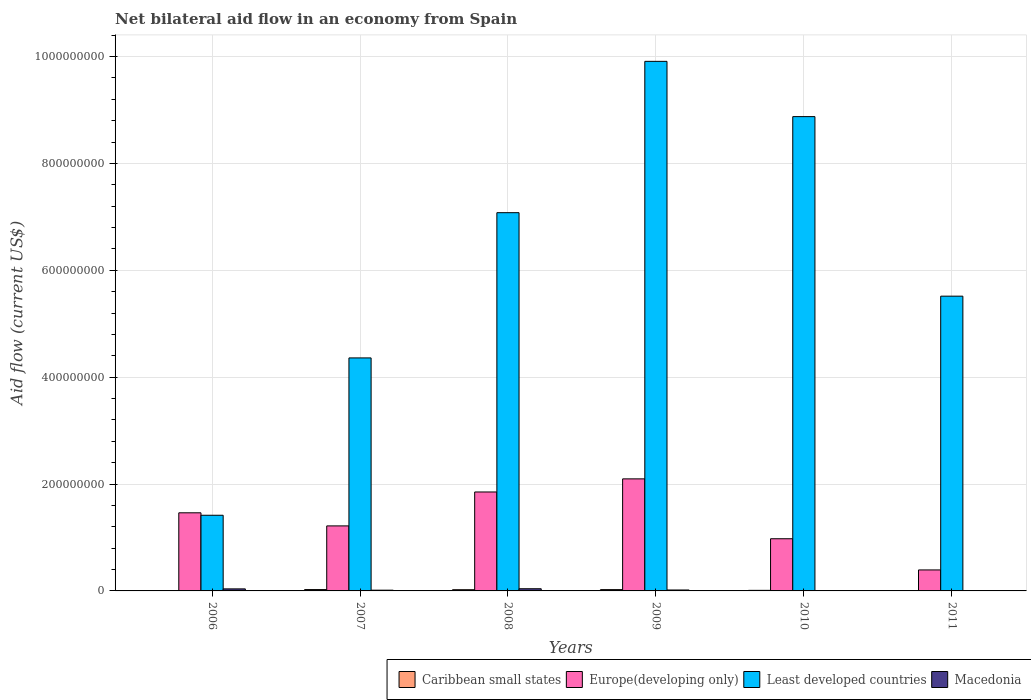How many different coloured bars are there?
Your answer should be compact. 4. Are the number of bars per tick equal to the number of legend labels?
Offer a terse response. Yes. Are the number of bars on each tick of the X-axis equal?
Keep it short and to the point. Yes. How many bars are there on the 1st tick from the left?
Offer a very short reply. 4. How many bars are there on the 6th tick from the right?
Your response must be concise. 4. What is the label of the 5th group of bars from the left?
Your response must be concise. 2010. What is the net bilateral aid flow in Macedonia in 2007?
Your answer should be compact. 1.38e+06. Across all years, what is the maximum net bilateral aid flow in Macedonia?
Keep it short and to the point. 4.07e+06. Across all years, what is the minimum net bilateral aid flow in Europe(developing only)?
Offer a terse response. 3.93e+07. What is the total net bilateral aid flow in Macedonia in the graph?
Ensure brevity in your answer.  1.14e+07. What is the difference between the net bilateral aid flow in Caribbean small states in 2006 and that in 2011?
Your answer should be very brief. -4.40e+05. What is the difference between the net bilateral aid flow in Caribbean small states in 2010 and the net bilateral aid flow in Macedonia in 2009?
Provide a succinct answer. -6.80e+05. What is the average net bilateral aid flow in Macedonia per year?
Your response must be concise. 1.90e+06. In the year 2010, what is the difference between the net bilateral aid flow in Least developed countries and net bilateral aid flow in Caribbean small states?
Your response must be concise. 8.87e+08. What is the ratio of the net bilateral aid flow in Least developed countries in 2007 to that in 2008?
Provide a succinct answer. 0.62. Is the net bilateral aid flow in Macedonia in 2008 less than that in 2009?
Provide a short and direct response. No. What is the difference between the highest and the second highest net bilateral aid flow in Macedonia?
Ensure brevity in your answer.  2.50e+05. What is the difference between the highest and the lowest net bilateral aid flow in Least developed countries?
Provide a succinct answer. 8.50e+08. Is the sum of the net bilateral aid flow in Least developed countries in 2009 and 2010 greater than the maximum net bilateral aid flow in Europe(developing only) across all years?
Keep it short and to the point. Yes. What does the 2nd bar from the left in 2009 represents?
Your answer should be compact. Europe(developing only). What does the 3rd bar from the right in 2007 represents?
Make the answer very short. Europe(developing only). Is it the case that in every year, the sum of the net bilateral aid flow in Europe(developing only) and net bilateral aid flow in Caribbean small states is greater than the net bilateral aid flow in Least developed countries?
Offer a terse response. No. Are all the bars in the graph horizontal?
Your answer should be compact. No. Does the graph contain any zero values?
Offer a very short reply. No. Where does the legend appear in the graph?
Keep it short and to the point. Bottom right. How many legend labels are there?
Give a very brief answer. 4. What is the title of the graph?
Your response must be concise. Net bilateral aid flow in an economy from Spain. What is the label or title of the Y-axis?
Your response must be concise. Aid flow (current US$). What is the Aid flow (current US$) of Caribbean small states in 2006?
Offer a terse response. 2.00e+05. What is the Aid flow (current US$) in Europe(developing only) in 2006?
Your answer should be compact. 1.46e+08. What is the Aid flow (current US$) of Least developed countries in 2006?
Your answer should be very brief. 1.42e+08. What is the Aid flow (current US$) in Macedonia in 2006?
Your answer should be very brief. 3.82e+06. What is the Aid flow (current US$) of Caribbean small states in 2007?
Your answer should be very brief. 2.53e+06. What is the Aid flow (current US$) in Europe(developing only) in 2007?
Your response must be concise. 1.22e+08. What is the Aid flow (current US$) of Least developed countries in 2007?
Your answer should be very brief. 4.36e+08. What is the Aid flow (current US$) of Macedonia in 2007?
Give a very brief answer. 1.38e+06. What is the Aid flow (current US$) in Caribbean small states in 2008?
Offer a very short reply. 2.26e+06. What is the Aid flow (current US$) of Europe(developing only) in 2008?
Your response must be concise. 1.85e+08. What is the Aid flow (current US$) in Least developed countries in 2008?
Provide a short and direct response. 7.08e+08. What is the Aid flow (current US$) in Macedonia in 2008?
Offer a very short reply. 4.07e+06. What is the Aid flow (current US$) of Caribbean small states in 2009?
Give a very brief answer. 2.43e+06. What is the Aid flow (current US$) of Europe(developing only) in 2009?
Your response must be concise. 2.10e+08. What is the Aid flow (current US$) in Least developed countries in 2009?
Offer a terse response. 9.91e+08. What is the Aid flow (current US$) in Macedonia in 2009?
Give a very brief answer. 1.75e+06. What is the Aid flow (current US$) of Caribbean small states in 2010?
Your response must be concise. 1.07e+06. What is the Aid flow (current US$) in Europe(developing only) in 2010?
Keep it short and to the point. 9.77e+07. What is the Aid flow (current US$) in Least developed countries in 2010?
Offer a very short reply. 8.88e+08. What is the Aid flow (current US$) in Caribbean small states in 2011?
Offer a very short reply. 6.40e+05. What is the Aid flow (current US$) of Europe(developing only) in 2011?
Give a very brief answer. 3.93e+07. What is the Aid flow (current US$) in Least developed countries in 2011?
Keep it short and to the point. 5.52e+08. Across all years, what is the maximum Aid flow (current US$) in Caribbean small states?
Your answer should be compact. 2.53e+06. Across all years, what is the maximum Aid flow (current US$) in Europe(developing only)?
Offer a terse response. 2.10e+08. Across all years, what is the maximum Aid flow (current US$) of Least developed countries?
Keep it short and to the point. 9.91e+08. Across all years, what is the maximum Aid flow (current US$) in Macedonia?
Provide a succinct answer. 4.07e+06. Across all years, what is the minimum Aid flow (current US$) in Caribbean small states?
Give a very brief answer. 2.00e+05. Across all years, what is the minimum Aid flow (current US$) of Europe(developing only)?
Your response must be concise. 3.93e+07. Across all years, what is the minimum Aid flow (current US$) of Least developed countries?
Keep it short and to the point. 1.42e+08. What is the total Aid flow (current US$) in Caribbean small states in the graph?
Provide a succinct answer. 9.13e+06. What is the total Aid flow (current US$) in Europe(developing only) in the graph?
Offer a very short reply. 8.00e+08. What is the total Aid flow (current US$) in Least developed countries in the graph?
Your response must be concise. 3.72e+09. What is the total Aid flow (current US$) in Macedonia in the graph?
Your response must be concise. 1.14e+07. What is the difference between the Aid flow (current US$) of Caribbean small states in 2006 and that in 2007?
Offer a terse response. -2.33e+06. What is the difference between the Aid flow (current US$) in Europe(developing only) in 2006 and that in 2007?
Provide a short and direct response. 2.45e+07. What is the difference between the Aid flow (current US$) in Least developed countries in 2006 and that in 2007?
Keep it short and to the point. -2.94e+08. What is the difference between the Aid flow (current US$) of Macedonia in 2006 and that in 2007?
Provide a succinct answer. 2.44e+06. What is the difference between the Aid flow (current US$) in Caribbean small states in 2006 and that in 2008?
Offer a terse response. -2.06e+06. What is the difference between the Aid flow (current US$) of Europe(developing only) in 2006 and that in 2008?
Offer a terse response. -3.90e+07. What is the difference between the Aid flow (current US$) in Least developed countries in 2006 and that in 2008?
Keep it short and to the point. -5.66e+08. What is the difference between the Aid flow (current US$) of Macedonia in 2006 and that in 2008?
Make the answer very short. -2.50e+05. What is the difference between the Aid flow (current US$) in Caribbean small states in 2006 and that in 2009?
Give a very brief answer. -2.23e+06. What is the difference between the Aid flow (current US$) in Europe(developing only) in 2006 and that in 2009?
Make the answer very short. -6.35e+07. What is the difference between the Aid flow (current US$) of Least developed countries in 2006 and that in 2009?
Make the answer very short. -8.50e+08. What is the difference between the Aid flow (current US$) in Macedonia in 2006 and that in 2009?
Give a very brief answer. 2.07e+06. What is the difference between the Aid flow (current US$) in Caribbean small states in 2006 and that in 2010?
Provide a short and direct response. -8.70e+05. What is the difference between the Aid flow (current US$) in Europe(developing only) in 2006 and that in 2010?
Ensure brevity in your answer.  4.85e+07. What is the difference between the Aid flow (current US$) in Least developed countries in 2006 and that in 2010?
Ensure brevity in your answer.  -7.46e+08. What is the difference between the Aid flow (current US$) in Macedonia in 2006 and that in 2010?
Your response must be concise. 3.47e+06. What is the difference between the Aid flow (current US$) in Caribbean small states in 2006 and that in 2011?
Your response must be concise. -4.40e+05. What is the difference between the Aid flow (current US$) of Europe(developing only) in 2006 and that in 2011?
Give a very brief answer. 1.07e+08. What is the difference between the Aid flow (current US$) of Least developed countries in 2006 and that in 2011?
Your answer should be compact. -4.10e+08. What is the difference between the Aid flow (current US$) in Macedonia in 2006 and that in 2011?
Offer a very short reply. 3.77e+06. What is the difference between the Aid flow (current US$) in Europe(developing only) in 2007 and that in 2008?
Offer a terse response. -6.35e+07. What is the difference between the Aid flow (current US$) of Least developed countries in 2007 and that in 2008?
Offer a terse response. -2.72e+08. What is the difference between the Aid flow (current US$) of Macedonia in 2007 and that in 2008?
Your answer should be very brief. -2.69e+06. What is the difference between the Aid flow (current US$) of Europe(developing only) in 2007 and that in 2009?
Your answer should be compact. -8.80e+07. What is the difference between the Aid flow (current US$) of Least developed countries in 2007 and that in 2009?
Provide a succinct answer. -5.55e+08. What is the difference between the Aid flow (current US$) in Macedonia in 2007 and that in 2009?
Provide a succinct answer. -3.70e+05. What is the difference between the Aid flow (current US$) in Caribbean small states in 2007 and that in 2010?
Your answer should be very brief. 1.46e+06. What is the difference between the Aid flow (current US$) in Europe(developing only) in 2007 and that in 2010?
Your answer should be very brief. 2.40e+07. What is the difference between the Aid flow (current US$) in Least developed countries in 2007 and that in 2010?
Offer a terse response. -4.52e+08. What is the difference between the Aid flow (current US$) in Macedonia in 2007 and that in 2010?
Offer a terse response. 1.03e+06. What is the difference between the Aid flow (current US$) in Caribbean small states in 2007 and that in 2011?
Ensure brevity in your answer.  1.89e+06. What is the difference between the Aid flow (current US$) of Europe(developing only) in 2007 and that in 2011?
Your answer should be very brief. 8.24e+07. What is the difference between the Aid flow (current US$) in Least developed countries in 2007 and that in 2011?
Your response must be concise. -1.16e+08. What is the difference between the Aid flow (current US$) of Macedonia in 2007 and that in 2011?
Your response must be concise. 1.33e+06. What is the difference between the Aid flow (current US$) of Caribbean small states in 2008 and that in 2009?
Give a very brief answer. -1.70e+05. What is the difference between the Aid flow (current US$) in Europe(developing only) in 2008 and that in 2009?
Ensure brevity in your answer.  -2.45e+07. What is the difference between the Aid flow (current US$) of Least developed countries in 2008 and that in 2009?
Your answer should be compact. -2.83e+08. What is the difference between the Aid flow (current US$) of Macedonia in 2008 and that in 2009?
Offer a very short reply. 2.32e+06. What is the difference between the Aid flow (current US$) in Caribbean small states in 2008 and that in 2010?
Give a very brief answer. 1.19e+06. What is the difference between the Aid flow (current US$) of Europe(developing only) in 2008 and that in 2010?
Your answer should be compact. 8.75e+07. What is the difference between the Aid flow (current US$) in Least developed countries in 2008 and that in 2010?
Offer a very short reply. -1.80e+08. What is the difference between the Aid flow (current US$) in Macedonia in 2008 and that in 2010?
Offer a terse response. 3.72e+06. What is the difference between the Aid flow (current US$) in Caribbean small states in 2008 and that in 2011?
Ensure brevity in your answer.  1.62e+06. What is the difference between the Aid flow (current US$) of Europe(developing only) in 2008 and that in 2011?
Offer a very short reply. 1.46e+08. What is the difference between the Aid flow (current US$) in Least developed countries in 2008 and that in 2011?
Provide a succinct answer. 1.56e+08. What is the difference between the Aid flow (current US$) of Macedonia in 2008 and that in 2011?
Your answer should be compact. 4.02e+06. What is the difference between the Aid flow (current US$) in Caribbean small states in 2009 and that in 2010?
Provide a short and direct response. 1.36e+06. What is the difference between the Aid flow (current US$) of Europe(developing only) in 2009 and that in 2010?
Offer a very short reply. 1.12e+08. What is the difference between the Aid flow (current US$) in Least developed countries in 2009 and that in 2010?
Your response must be concise. 1.03e+08. What is the difference between the Aid flow (current US$) of Macedonia in 2009 and that in 2010?
Provide a succinct answer. 1.40e+06. What is the difference between the Aid flow (current US$) in Caribbean small states in 2009 and that in 2011?
Make the answer very short. 1.79e+06. What is the difference between the Aid flow (current US$) of Europe(developing only) in 2009 and that in 2011?
Your answer should be compact. 1.70e+08. What is the difference between the Aid flow (current US$) in Least developed countries in 2009 and that in 2011?
Provide a short and direct response. 4.39e+08. What is the difference between the Aid flow (current US$) of Macedonia in 2009 and that in 2011?
Ensure brevity in your answer.  1.70e+06. What is the difference between the Aid flow (current US$) in Caribbean small states in 2010 and that in 2011?
Offer a very short reply. 4.30e+05. What is the difference between the Aid flow (current US$) in Europe(developing only) in 2010 and that in 2011?
Give a very brief answer. 5.84e+07. What is the difference between the Aid flow (current US$) of Least developed countries in 2010 and that in 2011?
Your answer should be very brief. 3.36e+08. What is the difference between the Aid flow (current US$) in Macedonia in 2010 and that in 2011?
Ensure brevity in your answer.  3.00e+05. What is the difference between the Aid flow (current US$) in Caribbean small states in 2006 and the Aid flow (current US$) in Europe(developing only) in 2007?
Your answer should be compact. -1.22e+08. What is the difference between the Aid flow (current US$) in Caribbean small states in 2006 and the Aid flow (current US$) in Least developed countries in 2007?
Provide a succinct answer. -4.36e+08. What is the difference between the Aid flow (current US$) of Caribbean small states in 2006 and the Aid flow (current US$) of Macedonia in 2007?
Make the answer very short. -1.18e+06. What is the difference between the Aid flow (current US$) in Europe(developing only) in 2006 and the Aid flow (current US$) in Least developed countries in 2007?
Keep it short and to the point. -2.90e+08. What is the difference between the Aid flow (current US$) in Europe(developing only) in 2006 and the Aid flow (current US$) in Macedonia in 2007?
Your answer should be very brief. 1.45e+08. What is the difference between the Aid flow (current US$) in Least developed countries in 2006 and the Aid flow (current US$) in Macedonia in 2007?
Keep it short and to the point. 1.40e+08. What is the difference between the Aid flow (current US$) of Caribbean small states in 2006 and the Aid flow (current US$) of Europe(developing only) in 2008?
Your answer should be compact. -1.85e+08. What is the difference between the Aid flow (current US$) in Caribbean small states in 2006 and the Aid flow (current US$) in Least developed countries in 2008?
Your answer should be very brief. -7.08e+08. What is the difference between the Aid flow (current US$) of Caribbean small states in 2006 and the Aid flow (current US$) of Macedonia in 2008?
Provide a short and direct response. -3.87e+06. What is the difference between the Aid flow (current US$) in Europe(developing only) in 2006 and the Aid flow (current US$) in Least developed countries in 2008?
Ensure brevity in your answer.  -5.62e+08. What is the difference between the Aid flow (current US$) in Europe(developing only) in 2006 and the Aid flow (current US$) in Macedonia in 2008?
Offer a terse response. 1.42e+08. What is the difference between the Aid flow (current US$) of Least developed countries in 2006 and the Aid flow (current US$) of Macedonia in 2008?
Keep it short and to the point. 1.38e+08. What is the difference between the Aid flow (current US$) of Caribbean small states in 2006 and the Aid flow (current US$) of Europe(developing only) in 2009?
Your answer should be very brief. -2.10e+08. What is the difference between the Aid flow (current US$) in Caribbean small states in 2006 and the Aid flow (current US$) in Least developed countries in 2009?
Your response must be concise. -9.91e+08. What is the difference between the Aid flow (current US$) of Caribbean small states in 2006 and the Aid flow (current US$) of Macedonia in 2009?
Your answer should be very brief. -1.55e+06. What is the difference between the Aid flow (current US$) of Europe(developing only) in 2006 and the Aid flow (current US$) of Least developed countries in 2009?
Give a very brief answer. -8.45e+08. What is the difference between the Aid flow (current US$) in Europe(developing only) in 2006 and the Aid flow (current US$) in Macedonia in 2009?
Make the answer very short. 1.44e+08. What is the difference between the Aid flow (current US$) of Least developed countries in 2006 and the Aid flow (current US$) of Macedonia in 2009?
Your answer should be very brief. 1.40e+08. What is the difference between the Aid flow (current US$) in Caribbean small states in 2006 and the Aid flow (current US$) in Europe(developing only) in 2010?
Your answer should be very brief. -9.75e+07. What is the difference between the Aid flow (current US$) of Caribbean small states in 2006 and the Aid flow (current US$) of Least developed countries in 2010?
Provide a succinct answer. -8.88e+08. What is the difference between the Aid flow (current US$) in Caribbean small states in 2006 and the Aid flow (current US$) in Macedonia in 2010?
Provide a succinct answer. -1.50e+05. What is the difference between the Aid flow (current US$) in Europe(developing only) in 2006 and the Aid flow (current US$) in Least developed countries in 2010?
Make the answer very short. -7.42e+08. What is the difference between the Aid flow (current US$) in Europe(developing only) in 2006 and the Aid flow (current US$) in Macedonia in 2010?
Your answer should be compact. 1.46e+08. What is the difference between the Aid flow (current US$) of Least developed countries in 2006 and the Aid flow (current US$) of Macedonia in 2010?
Your answer should be compact. 1.41e+08. What is the difference between the Aid flow (current US$) of Caribbean small states in 2006 and the Aid flow (current US$) of Europe(developing only) in 2011?
Provide a short and direct response. -3.91e+07. What is the difference between the Aid flow (current US$) in Caribbean small states in 2006 and the Aid flow (current US$) in Least developed countries in 2011?
Ensure brevity in your answer.  -5.51e+08. What is the difference between the Aid flow (current US$) of Caribbean small states in 2006 and the Aid flow (current US$) of Macedonia in 2011?
Your response must be concise. 1.50e+05. What is the difference between the Aid flow (current US$) in Europe(developing only) in 2006 and the Aid flow (current US$) in Least developed countries in 2011?
Your response must be concise. -4.05e+08. What is the difference between the Aid flow (current US$) in Europe(developing only) in 2006 and the Aid flow (current US$) in Macedonia in 2011?
Make the answer very short. 1.46e+08. What is the difference between the Aid flow (current US$) of Least developed countries in 2006 and the Aid flow (current US$) of Macedonia in 2011?
Provide a succinct answer. 1.42e+08. What is the difference between the Aid flow (current US$) of Caribbean small states in 2007 and the Aid flow (current US$) of Europe(developing only) in 2008?
Ensure brevity in your answer.  -1.83e+08. What is the difference between the Aid flow (current US$) of Caribbean small states in 2007 and the Aid flow (current US$) of Least developed countries in 2008?
Offer a terse response. -7.05e+08. What is the difference between the Aid flow (current US$) of Caribbean small states in 2007 and the Aid flow (current US$) of Macedonia in 2008?
Your answer should be very brief. -1.54e+06. What is the difference between the Aid flow (current US$) of Europe(developing only) in 2007 and the Aid flow (current US$) of Least developed countries in 2008?
Provide a succinct answer. -5.86e+08. What is the difference between the Aid flow (current US$) of Europe(developing only) in 2007 and the Aid flow (current US$) of Macedonia in 2008?
Your response must be concise. 1.18e+08. What is the difference between the Aid flow (current US$) of Least developed countries in 2007 and the Aid flow (current US$) of Macedonia in 2008?
Give a very brief answer. 4.32e+08. What is the difference between the Aid flow (current US$) of Caribbean small states in 2007 and the Aid flow (current US$) of Europe(developing only) in 2009?
Provide a succinct answer. -2.07e+08. What is the difference between the Aid flow (current US$) in Caribbean small states in 2007 and the Aid flow (current US$) in Least developed countries in 2009?
Your response must be concise. -9.89e+08. What is the difference between the Aid flow (current US$) in Caribbean small states in 2007 and the Aid flow (current US$) in Macedonia in 2009?
Your answer should be very brief. 7.80e+05. What is the difference between the Aid flow (current US$) in Europe(developing only) in 2007 and the Aid flow (current US$) in Least developed countries in 2009?
Your answer should be compact. -8.69e+08. What is the difference between the Aid flow (current US$) in Europe(developing only) in 2007 and the Aid flow (current US$) in Macedonia in 2009?
Offer a terse response. 1.20e+08. What is the difference between the Aid flow (current US$) in Least developed countries in 2007 and the Aid flow (current US$) in Macedonia in 2009?
Your answer should be very brief. 4.34e+08. What is the difference between the Aid flow (current US$) in Caribbean small states in 2007 and the Aid flow (current US$) in Europe(developing only) in 2010?
Keep it short and to the point. -9.51e+07. What is the difference between the Aid flow (current US$) in Caribbean small states in 2007 and the Aid flow (current US$) in Least developed countries in 2010?
Your answer should be compact. -8.85e+08. What is the difference between the Aid flow (current US$) in Caribbean small states in 2007 and the Aid flow (current US$) in Macedonia in 2010?
Make the answer very short. 2.18e+06. What is the difference between the Aid flow (current US$) in Europe(developing only) in 2007 and the Aid flow (current US$) in Least developed countries in 2010?
Keep it short and to the point. -7.66e+08. What is the difference between the Aid flow (current US$) in Europe(developing only) in 2007 and the Aid flow (current US$) in Macedonia in 2010?
Provide a short and direct response. 1.21e+08. What is the difference between the Aid flow (current US$) in Least developed countries in 2007 and the Aid flow (current US$) in Macedonia in 2010?
Offer a very short reply. 4.36e+08. What is the difference between the Aid flow (current US$) in Caribbean small states in 2007 and the Aid flow (current US$) in Europe(developing only) in 2011?
Your answer should be very brief. -3.68e+07. What is the difference between the Aid flow (current US$) of Caribbean small states in 2007 and the Aid flow (current US$) of Least developed countries in 2011?
Offer a terse response. -5.49e+08. What is the difference between the Aid flow (current US$) in Caribbean small states in 2007 and the Aid flow (current US$) in Macedonia in 2011?
Provide a short and direct response. 2.48e+06. What is the difference between the Aid flow (current US$) in Europe(developing only) in 2007 and the Aid flow (current US$) in Least developed countries in 2011?
Your answer should be compact. -4.30e+08. What is the difference between the Aid flow (current US$) of Europe(developing only) in 2007 and the Aid flow (current US$) of Macedonia in 2011?
Your response must be concise. 1.22e+08. What is the difference between the Aid flow (current US$) in Least developed countries in 2007 and the Aid flow (current US$) in Macedonia in 2011?
Your answer should be very brief. 4.36e+08. What is the difference between the Aid flow (current US$) in Caribbean small states in 2008 and the Aid flow (current US$) in Europe(developing only) in 2009?
Give a very brief answer. -2.07e+08. What is the difference between the Aid flow (current US$) of Caribbean small states in 2008 and the Aid flow (current US$) of Least developed countries in 2009?
Make the answer very short. -9.89e+08. What is the difference between the Aid flow (current US$) of Caribbean small states in 2008 and the Aid flow (current US$) of Macedonia in 2009?
Provide a short and direct response. 5.10e+05. What is the difference between the Aid flow (current US$) of Europe(developing only) in 2008 and the Aid flow (current US$) of Least developed countries in 2009?
Give a very brief answer. -8.06e+08. What is the difference between the Aid flow (current US$) of Europe(developing only) in 2008 and the Aid flow (current US$) of Macedonia in 2009?
Keep it short and to the point. 1.83e+08. What is the difference between the Aid flow (current US$) of Least developed countries in 2008 and the Aid flow (current US$) of Macedonia in 2009?
Your response must be concise. 7.06e+08. What is the difference between the Aid flow (current US$) in Caribbean small states in 2008 and the Aid flow (current US$) in Europe(developing only) in 2010?
Provide a succinct answer. -9.54e+07. What is the difference between the Aid flow (current US$) of Caribbean small states in 2008 and the Aid flow (current US$) of Least developed countries in 2010?
Keep it short and to the point. -8.85e+08. What is the difference between the Aid flow (current US$) in Caribbean small states in 2008 and the Aid flow (current US$) in Macedonia in 2010?
Offer a terse response. 1.91e+06. What is the difference between the Aid flow (current US$) in Europe(developing only) in 2008 and the Aid flow (current US$) in Least developed countries in 2010?
Make the answer very short. -7.03e+08. What is the difference between the Aid flow (current US$) of Europe(developing only) in 2008 and the Aid flow (current US$) of Macedonia in 2010?
Give a very brief answer. 1.85e+08. What is the difference between the Aid flow (current US$) of Least developed countries in 2008 and the Aid flow (current US$) of Macedonia in 2010?
Make the answer very short. 7.08e+08. What is the difference between the Aid flow (current US$) in Caribbean small states in 2008 and the Aid flow (current US$) in Europe(developing only) in 2011?
Provide a succinct answer. -3.70e+07. What is the difference between the Aid flow (current US$) in Caribbean small states in 2008 and the Aid flow (current US$) in Least developed countries in 2011?
Offer a terse response. -5.49e+08. What is the difference between the Aid flow (current US$) in Caribbean small states in 2008 and the Aid flow (current US$) in Macedonia in 2011?
Offer a terse response. 2.21e+06. What is the difference between the Aid flow (current US$) in Europe(developing only) in 2008 and the Aid flow (current US$) in Least developed countries in 2011?
Provide a succinct answer. -3.66e+08. What is the difference between the Aid flow (current US$) of Europe(developing only) in 2008 and the Aid flow (current US$) of Macedonia in 2011?
Provide a short and direct response. 1.85e+08. What is the difference between the Aid flow (current US$) of Least developed countries in 2008 and the Aid flow (current US$) of Macedonia in 2011?
Make the answer very short. 7.08e+08. What is the difference between the Aid flow (current US$) of Caribbean small states in 2009 and the Aid flow (current US$) of Europe(developing only) in 2010?
Make the answer very short. -9.52e+07. What is the difference between the Aid flow (current US$) in Caribbean small states in 2009 and the Aid flow (current US$) in Least developed countries in 2010?
Keep it short and to the point. -8.85e+08. What is the difference between the Aid flow (current US$) of Caribbean small states in 2009 and the Aid flow (current US$) of Macedonia in 2010?
Offer a terse response. 2.08e+06. What is the difference between the Aid flow (current US$) in Europe(developing only) in 2009 and the Aid flow (current US$) in Least developed countries in 2010?
Your answer should be very brief. -6.78e+08. What is the difference between the Aid flow (current US$) in Europe(developing only) in 2009 and the Aid flow (current US$) in Macedonia in 2010?
Your response must be concise. 2.09e+08. What is the difference between the Aid flow (current US$) in Least developed countries in 2009 and the Aid flow (current US$) in Macedonia in 2010?
Your answer should be very brief. 9.91e+08. What is the difference between the Aid flow (current US$) of Caribbean small states in 2009 and the Aid flow (current US$) of Europe(developing only) in 2011?
Give a very brief answer. -3.69e+07. What is the difference between the Aid flow (current US$) in Caribbean small states in 2009 and the Aid flow (current US$) in Least developed countries in 2011?
Ensure brevity in your answer.  -5.49e+08. What is the difference between the Aid flow (current US$) in Caribbean small states in 2009 and the Aid flow (current US$) in Macedonia in 2011?
Your response must be concise. 2.38e+06. What is the difference between the Aid flow (current US$) of Europe(developing only) in 2009 and the Aid flow (current US$) of Least developed countries in 2011?
Provide a succinct answer. -3.42e+08. What is the difference between the Aid flow (current US$) of Europe(developing only) in 2009 and the Aid flow (current US$) of Macedonia in 2011?
Your answer should be very brief. 2.10e+08. What is the difference between the Aid flow (current US$) of Least developed countries in 2009 and the Aid flow (current US$) of Macedonia in 2011?
Provide a succinct answer. 9.91e+08. What is the difference between the Aid flow (current US$) in Caribbean small states in 2010 and the Aid flow (current US$) in Europe(developing only) in 2011?
Offer a very short reply. -3.82e+07. What is the difference between the Aid flow (current US$) of Caribbean small states in 2010 and the Aid flow (current US$) of Least developed countries in 2011?
Offer a very short reply. -5.51e+08. What is the difference between the Aid flow (current US$) of Caribbean small states in 2010 and the Aid flow (current US$) of Macedonia in 2011?
Provide a succinct answer. 1.02e+06. What is the difference between the Aid flow (current US$) in Europe(developing only) in 2010 and the Aid flow (current US$) in Least developed countries in 2011?
Your answer should be compact. -4.54e+08. What is the difference between the Aid flow (current US$) in Europe(developing only) in 2010 and the Aid flow (current US$) in Macedonia in 2011?
Offer a terse response. 9.76e+07. What is the difference between the Aid flow (current US$) of Least developed countries in 2010 and the Aid flow (current US$) of Macedonia in 2011?
Keep it short and to the point. 8.88e+08. What is the average Aid flow (current US$) of Caribbean small states per year?
Provide a succinct answer. 1.52e+06. What is the average Aid flow (current US$) of Europe(developing only) per year?
Provide a succinct answer. 1.33e+08. What is the average Aid flow (current US$) in Least developed countries per year?
Your response must be concise. 6.19e+08. What is the average Aid flow (current US$) of Macedonia per year?
Give a very brief answer. 1.90e+06. In the year 2006, what is the difference between the Aid flow (current US$) in Caribbean small states and Aid flow (current US$) in Europe(developing only)?
Make the answer very short. -1.46e+08. In the year 2006, what is the difference between the Aid flow (current US$) in Caribbean small states and Aid flow (current US$) in Least developed countries?
Make the answer very short. -1.41e+08. In the year 2006, what is the difference between the Aid flow (current US$) in Caribbean small states and Aid flow (current US$) in Macedonia?
Offer a terse response. -3.62e+06. In the year 2006, what is the difference between the Aid flow (current US$) in Europe(developing only) and Aid flow (current US$) in Least developed countries?
Give a very brief answer. 4.58e+06. In the year 2006, what is the difference between the Aid flow (current US$) in Europe(developing only) and Aid flow (current US$) in Macedonia?
Keep it short and to the point. 1.42e+08. In the year 2006, what is the difference between the Aid flow (current US$) of Least developed countries and Aid flow (current US$) of Macedonia?
Ensure brevity in your answer.  1.38e+08. In the year 2007, what is the difference between the Aid flow (current US$) in Caribbean small states and Aid flow (current US$) in Europe(developing only)?
Provide a succinct answer. -1.19e+08. In the year 2007, what is the difference between the Aid flow (current US$) in Caribbean small states and Aid flow (current US$) in Least developed countries?
Make the answer very short. -4.34e+08. In the year 2007, what is the difference between the Aid flow (current US$) in Caribbean small states and Aid flow (current US$) in Macedonia?
Give a very brief answer. 1.15e+06. In the year 2007, what is the difference between the Aid flow (current US$) of Europe(developing only) and Aid flow (current US$) of Least developed countries?
Provide a succinct answer. -3.14e+08. In the year 2007, what is the difference between the Aid flow (current US$) of Europe(developing only) and Aid flow (current US$) of Macedonia?
Provide a succinct answer. 1.20e+08. In the year 2007, what is the difference between the Aid flow (current US$) in Least developed countries and Aid flow (current US$) in Macedonia?
Your answer should be very brief. 4.35e+08. In the year 2008, what is the difference between the Aid flow (current US$) in Caribbean small states and Aid flow (current US$) in Europe(developing only)?
Your answer should be compact. -1.83e+08. In the year 2008, what is the difference between the Aid flow (current US$) in Caribbean small states and Aid flow (current US$) in Least developed countries?
Your answer should be very brief. -7.06e+08. In the year 2008, what is the difference between the Aid flow (current US$) in Caribbean small states and Aid flow (current US$) in Macedonia?
Provide a short and direct response. -1.81e+06. In the year 2008, what is the difference between the Aid flow (current US$) of Europe(developing only) and Aid flow (current US$) of Least developed countries?
Provide a short and direct response. -5.23e+08. In the year 2008, what is the difference between the Aid flow (current US$) in Europe(developing only) and Aid flow (current US$) in Macedonia?
Make the answer very short. 1.81e+08. In the year 2008, what is the difference between the Aid flow (current US$) in Least developed countries and Aid flow (current US$) in Macedonia?
Your answer should be very brief. 7.04e+08. In the year 2009, what is the difference between the Aid flow (current US$) in Caribbean small states and Aid flow (current US$) in Europe(developing only)?
Provide a succinct answer. -2.07e+08. In the year 2009, what is the difference between the Aid flow (current US$) of Caribbean small states and Aid flow (current US$) of Least developed countries?
Offer a very short reply. -9.89e+08. In the year 2009, what is the difference between the Aid flow (current US$) in Caribbean small states and Aid flow (current US$) in Macedonia?
Provide a short and direct response. 6.80e+05. In the year 2009, what is the difference between the Aid flow (current US$) of Europe(developing only) and Aid flow (current US$) of Least developed countries?
Your response must be concise. -7.81e+08. In the year 2009, what is the difference between the Aid flow (current US$) of Europe(developing only) and Aid flow (current US$) of Macedonia?
Your answer should be compact. 2.08e+08. In the year 2009, what is the difference between the Aid flow (current US$) in Least developed countries and Aid flow (current US$) in Macedonia?
Make the answer very short. 9.89e+08. In the year 2010, what is the difference between the Aid flow (current US$) of Caribbean small states and Aid flow (current US$) of Europe(developing only)?
Provide a short and direct response. -9.66e+07. In the year 2010, what is the difference between the Aid flow (current US$) in Caribbean small states and Aid flow (current US$) in Least developed countries?
Provide a short and direct response. -8.87e+08. In the year 2010, what is the difference between the Aid flow (current US$) in Caribbean small states and Aid flow (current US$) in Macedonia?
Your answer should be compact. 7.20e+05. In the year 2010, what is the difference between the Aid flow (current US$) of Europe(developing only) and Aid flow (current US$) of Least developed countries?
Give a very brief answer. -7.90e+08. In the year 2010, what is the difference between the Aid flow (current US$) in Europe(developing only) and Aid flow (current US$) in Macedonia?
Your answer should be very brief. 9.73e+07. In the year 2010, what is the difference between the Aid flow (current US$) of Least developed countries and Aid flow (current US$) of Macedonia?
Ensure brevity in your answer.  8.87e+08. In the year 2011, what is the difference between the Aid flow (current US$) of Caribbean small states and Aid flow (current US$) of Europe(developing only)?
Your answer should be compact. -3.86e+07. In the year 2011, what is the difference between the Aid flow (current US$) of Caribbean small states and Aid flow (current US$) of Least developed countries?
Provide a short and direct response. -5.51e+08. In the year 2011, what is the difference between the Aid flow (current US$) in Caribbean small states and Aid flow (current US$) in Macedonia?
Your response must be concise. 5.90e+05. In the year 2011, what is the difference between the Aid flow (current US$) in Europe(developing only) and Aid flow (current US$) in Least developed countries?
Ensure brevity in your answer.  -5.12e+08. In the year 2011, what is the difference between the Aid flow (current US$) of Europe(developing only) and Aid flow (current US$) of Macedonia?
Ensure brevity in your answer.  3.92e+07. In the year 2011, what is the difference between the Aid flow (current US$) in Least developed countries and Aid flow (current US$) in Macedonia?
Ensure brevity in your answer.  5.52e+08. What is the ratio of the Aid flow (current US$) in Caribbean small states in 2006 to that in 2007?
Keep it short and to the point. 0.08. What is the ratio of the Aid flow (current US$) of Europe(developing only) in 2006 to that in 2007?
Keep it short and to the point. 1.2. What is the ratio of the Aid flow (current US$) in Least developed countries in 2006 to that in 2007?
Your response must be concise. 0.32. What is the ratio of the Aid flow (current US$) of Macedonia in 2006 to that in 2007?
Give a very brief answer. 2.77. What is the ratio of the Aid flow (current US$) in Caribbean small states in 2006 to that in 2008?
Provide a succinct answer. 0.09. What is the ratio of the Aid flow (current US$) in Europe(developing only) in 2006 to that in 2008?
Your response must be concise. 0.79. What is the ratio of the Aid flow (current US$) of Least developed countries in 2006 to that in 2008?
Your answer should be compact. 0.2. What is the ratio of the Aid flow (current US$) in Macedonia in 2006 to that in 2008?
Offer a very short reply. 0.94. What is the ratio of the Aid flow (current US$) in Caribbean small states in 2006 to that in 2009?
Your response must be concise. 0.08. What is the ratio of the Aid flow (current US$) of Europe(developing only) in 2006 to that in 2009?
Provide a succinct answer. 0.7. What is the ratio of the Aid flow (current US$) in Least developed countries in 2006 to that in 2009?
Make the answer very short. 0.14. What is the ratio of the Aid flow (current US$) in Macedonia in 2006 to that in 2009?
Your response must be concise. 2.18. What is the ratio of the Aid flow (current US$) in Caribbean small states in 2006 to that in 2010?
Provide a short and direct response. 0.19. What is the ratio of the Aid flow (current US$) of Europe(developing only) in 2006 to that in 2010?
Give a very brief answer. 1.5. What is the ratio of the Aid flow (current US$) in Least developed countries in 2006 to that in 2010?
Ensure brevity in your answer.  0.16. What is the ratio of the Aid flow (current US$) of Macedonia in 2006 to that in 2010?
Your response must be concise. 10.91. What is the ratio of the Aid flow (current US$) of Caribbean small states in 2006 to that in 2011?
Your response must be concise. 0.31. What is the ratio of the Aid flow (current US$) of Europe(developing only) in 2006 to that in 2011?
Your response must be concise. 3.72. What is the ratio of the Aid flow (current US$) in Least developed countries in 2006 to that in 2011?
Your response must be concise. 0.26. What is the ratio of the Aid flow (current US$) in Macedonia in 2006 to that in 2011?
Provide a short and direct response. 76.4. What is the ratio of the Aid flow (current US$) in Caribbean small states in 2007 to that in 2008?
Provide a short and direct response. 1.12. What is the ratio of the Aid flow (current US$) of Europe(developing only) in 2007 to that in 2008?
Your answer should be very brief. 0.66. What is the ratio of the Aid flow (current US$) of Least developed countries in 2007 to that in 2008?
Ensure brevity in your answer.  0.62. What is the ratio of the Aid flow (current US$) in Macedonia in 2007 to that in 2008?
Make the answer very short. 0.34. What is the ratio of the Aid flow (current US$) in Caribbean small states in 2007 to that in 2009?
Ensure brevity in your answer.  1.04. What is the ratio of the Aid flow (current US$) of Europe(developing only) in 2007 to that in 2009?
Offer a very short reply. 0.58. What is the ratio of the Aid flow (current US$) in Least developed countries in 2007 to that in 2009?
Make the answer very short. 0.44. What is the ratio of the Aid flow (current US$) of Macedonia in 2007 to that in 2009?
Keep it short and to the point. 0.79. What is the ratio of the Aid flow (current US$) of Caribbean small states in 2007 to that in 2010?
Offer a very short reply. 2.36. What is the ratio of the Aid flow (current US$) of Europe(developing only) in 2007 to that in 2010?
Provide a succinct answer. 1.25. What is the ratio of the Aid flow (current US$) of Least developed countries in 2007 to that in 2010?
Make the answer very short. 0.49. What is the ratio of the Aid flow (current US$) in Macedonia in 2007 to that in 2010?
Your response must be concise. 3.94. What is the ratio of the Aid flow (current US$) in Caribbean small states in 2007 to that in 2011?
Offer a terse response. 3.95. What is the ratio of the Aid flow (current US$) of Europe(developing only) in 2007 to that in 2011?
Your answer should be compact. 3.1. What is the ratio of the Aid flow (current US$) in Least developed countries in 2007 to that in 2011?
Your answer should be compact. 0.79. What is the ratio of the Aid flow (current US$) in Macedonia in 2007 to that in 2011?
Ensure brevity in your answer.  27.6. What is the ratio of the Aid flow (current US$) of Caribbean small states in 2008 to that in 2009?
Offer a very short reply. 0.93. What is the ratio of the Aid flow (current US$) of Europe(developing only) in 2008 to that in 2009?
Provide a short and direct response. 0.88. What is the ratio of the Aid flow (current US$) of Least developed countries in 2008 to that in 2009?
Offer a terse response. 0.71. What is the ratio of the Aid flow (current US$) of Macedonia in 2008 to that in 2009?
Keep it short and to the point. 2.33. What is the ratio of the Aid flow (current US$) in Caribbean small states in 2008 to that in 2010?
Offer a very short reply. 2.11. What is the ratio of the Aid flow (current US$) in Europe(developing only) in 2008 to that in 2010?
Offer a very short reply. 1.9. What is the ratio of the Aid flow (current US$) of Least developed countries in 2008 to that in 2010?
Ensure brevity in your answer.  0.8. What is the ratio of the Aid flow (current US$) of Macedonia in 2008 to that in 2010?
Your response must be concise. 11.63. What is the ratio of the Aid flow (current US$) in Caribbean small states in 2008 to that in 2011?
Your answer should be very brief. 3.53. What is the ratio of the Aid flow (current US$) in Europe(developing only) in 2008 to that in 2011?
Offer a terse response. 4.71. What is the ratio of the Aid flow (current US$) in Least developed countries in 2008 to that in 2011?
Your answer should be compact. 1.28. What is the ratio of the Aid flow (current US$) of Macedonia in 2008 to that in 2011?
Make the answer very short. 81.4. What is the ratio of the Aid flow (current US$) of Caribbean small states in 2009 to that in 2010?
Offer a terse response. 2.27. What is the ratio of the Aid flow (current US$) in Europe(developing only) in 2009 to that in 2010?
Your response must be concise. 2.15. What is the ratio of the Aid flow (current US$) of Least developed countries in 2009 to that in 2010?
Make the answer very short. 1.12. What is the ratio of the Aid flow (current US$) of Caribbean small states in 2009 to that in 2011?
Your answer should be compact. 3.8. What is the ratio of the Aid flow (current US$) of Europe(developing only) in 2009 to that in 2011?
Your answer should be compact. 5.34. What is the ratio of the Aid flow (current US$) of Least developed countries in 2009 to that in 2011?
Make the answer very short. 1.8. What is the ratio of the Aid flow (current US$) in Caribbean small states in 2010 to that in 2011?
Keep it short and to the point. 1.67. What is the ratio of the Aid flow (current US$) in Europe(developing only) in 2010 to that in 2011?
Provide a short and direct response. 2.49. What is the ratio of the Aid flow (current US$) of Least developed countries in 2010 to that in 2011?
Your answer should be compact. 1.61. What is the ratio of the Aid flow (current US$) in Macedonia in 2010 to that in 2011?
Provide a succinct answer. 7. What is the difference between the highest and the second highest Aid flow (current US$) of Caribbean small states?
Offer a terse response. 1.00e+05. What is the difference between the highest and the second highest Aid flow (current US$) of Europe(developing only)?
Make the answer very short. 2.45e+07. What is the difference between the highest and the second highest Aid flow (current US$) of Least developed countries?
Offer a very short reply. 1.03e+08. What is the difference between the highest and the second highest Aid flow (current US$) of Macedonia?
Your answer should be very brief. 2.50e+05. What is the difference between the highest and the lowest Aid flow (current US$) in Caribbean small states?
Give a very brief answer. 2.33e+06. What is the difference between the highest and the lowest Aid flow (current US$) in Europe(developing only)?
Your response must be concise. 1.70e+08. What is the difference between the highest and the lowest Aid flow (current US$) of Least developed countries?
Make the answer very short. 8.50e+08. What is the difference between the highest and the lowest Aid flow (current US$) in Macedonia?
Offer a very short reply. 4.02e+06. 